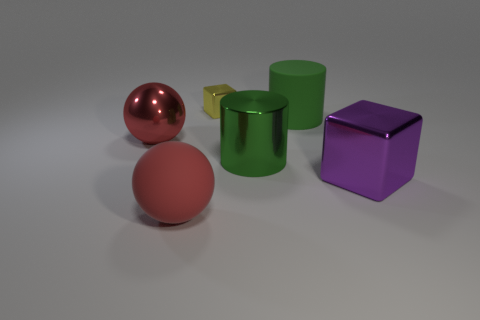How many red objects are the same size as the yellow thing?
Keep it short and to the point. 0. What material is the cube behind the large rubber object on the right side of the small yellow thing?
Your answer should be very brief. Metal. What shape is the metallic object that is left of the ball to the right of the sphere that is behind the large shiny block?
Your answer should be compact. Sphere. Does the object that is in front of the big purple object have the same shape as the red object behind the large purple shiny block?
Keep it short and to the point. Yes. What number of other objects are the same material as the tiny yellow thing?
Keep it short and to the point. 3. There is a red thing that is made of the same material as the big purple cube; what shape is it?
Make the answer very short. Sphere. Does the purple metallic block have the same size as the yellow thing?
Make the answer very short. No. There is a metal thing that is to the left of the red sphere in front of the large red metal thing; what size is it?
Make the answer very short. Large. What shape is the big matte object that is the same color as the big metal cylinder?
Keep it short and to the point. Cylinder. What number of cubes are yellow things or red objects?
Provide a short and direct response. 1. 